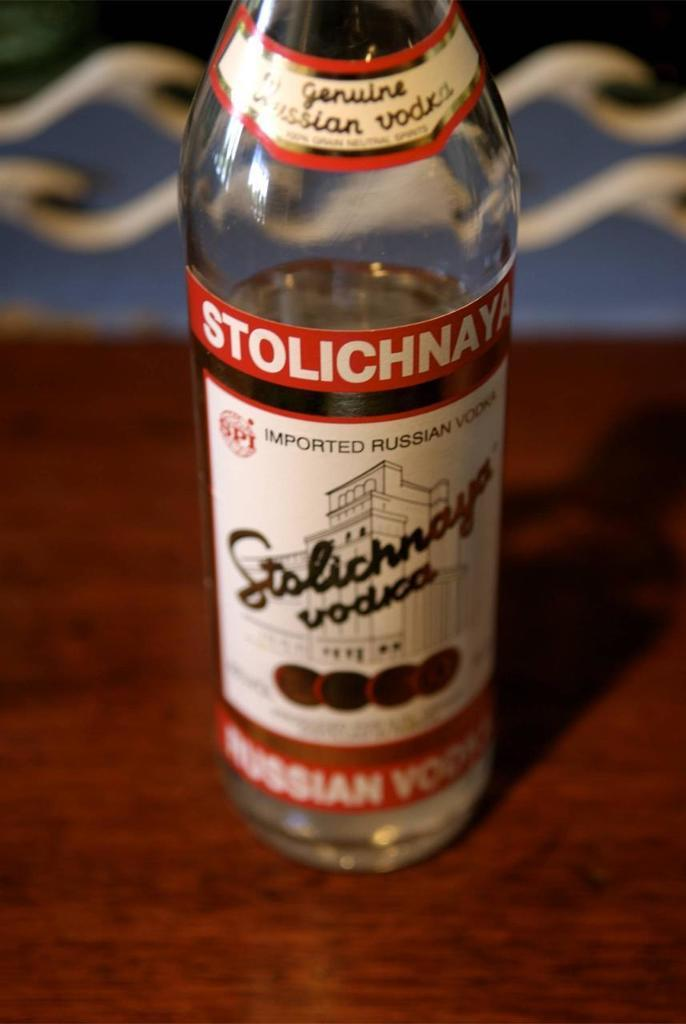What object in the image appears to be missing a part? There is a truncated bottle in the image. Reasoning: Leting: Let's think step by step in order to produce the conversation. We start by identifying the main subject in the image, which is the truncated bottle. The question is designed to elicit a specific detail about the image that object that is known from the provided fact. Absurd Question/Answer: What type of scarf is being worn by the committee in the image? There is no committee or scarf present in the image; it only features a truncated bottle. How much sand can be seen in the image? There is no sand present in the image; it only features a truncated bottle. 